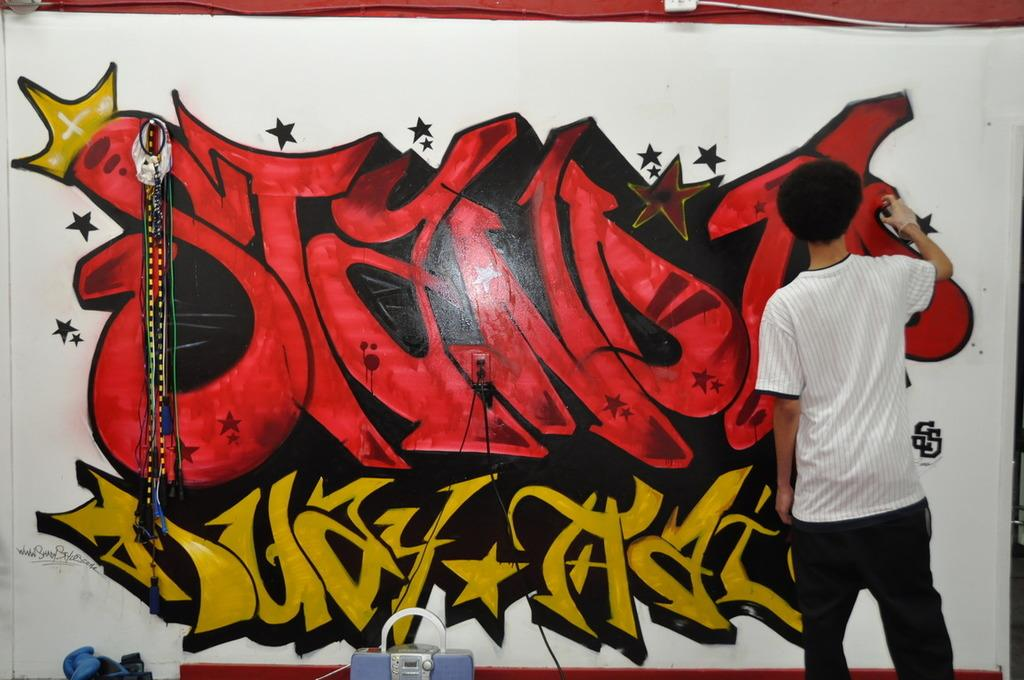What is the person in the image doing? The person is painting a wall. What is the person holding while painting the wall? The person is holding a spray. What other items can be seen in the image? There is a tool kit, an electrical wire, and a box in the image. How many eggs are visible in the image? There are no eggs present in the image. 